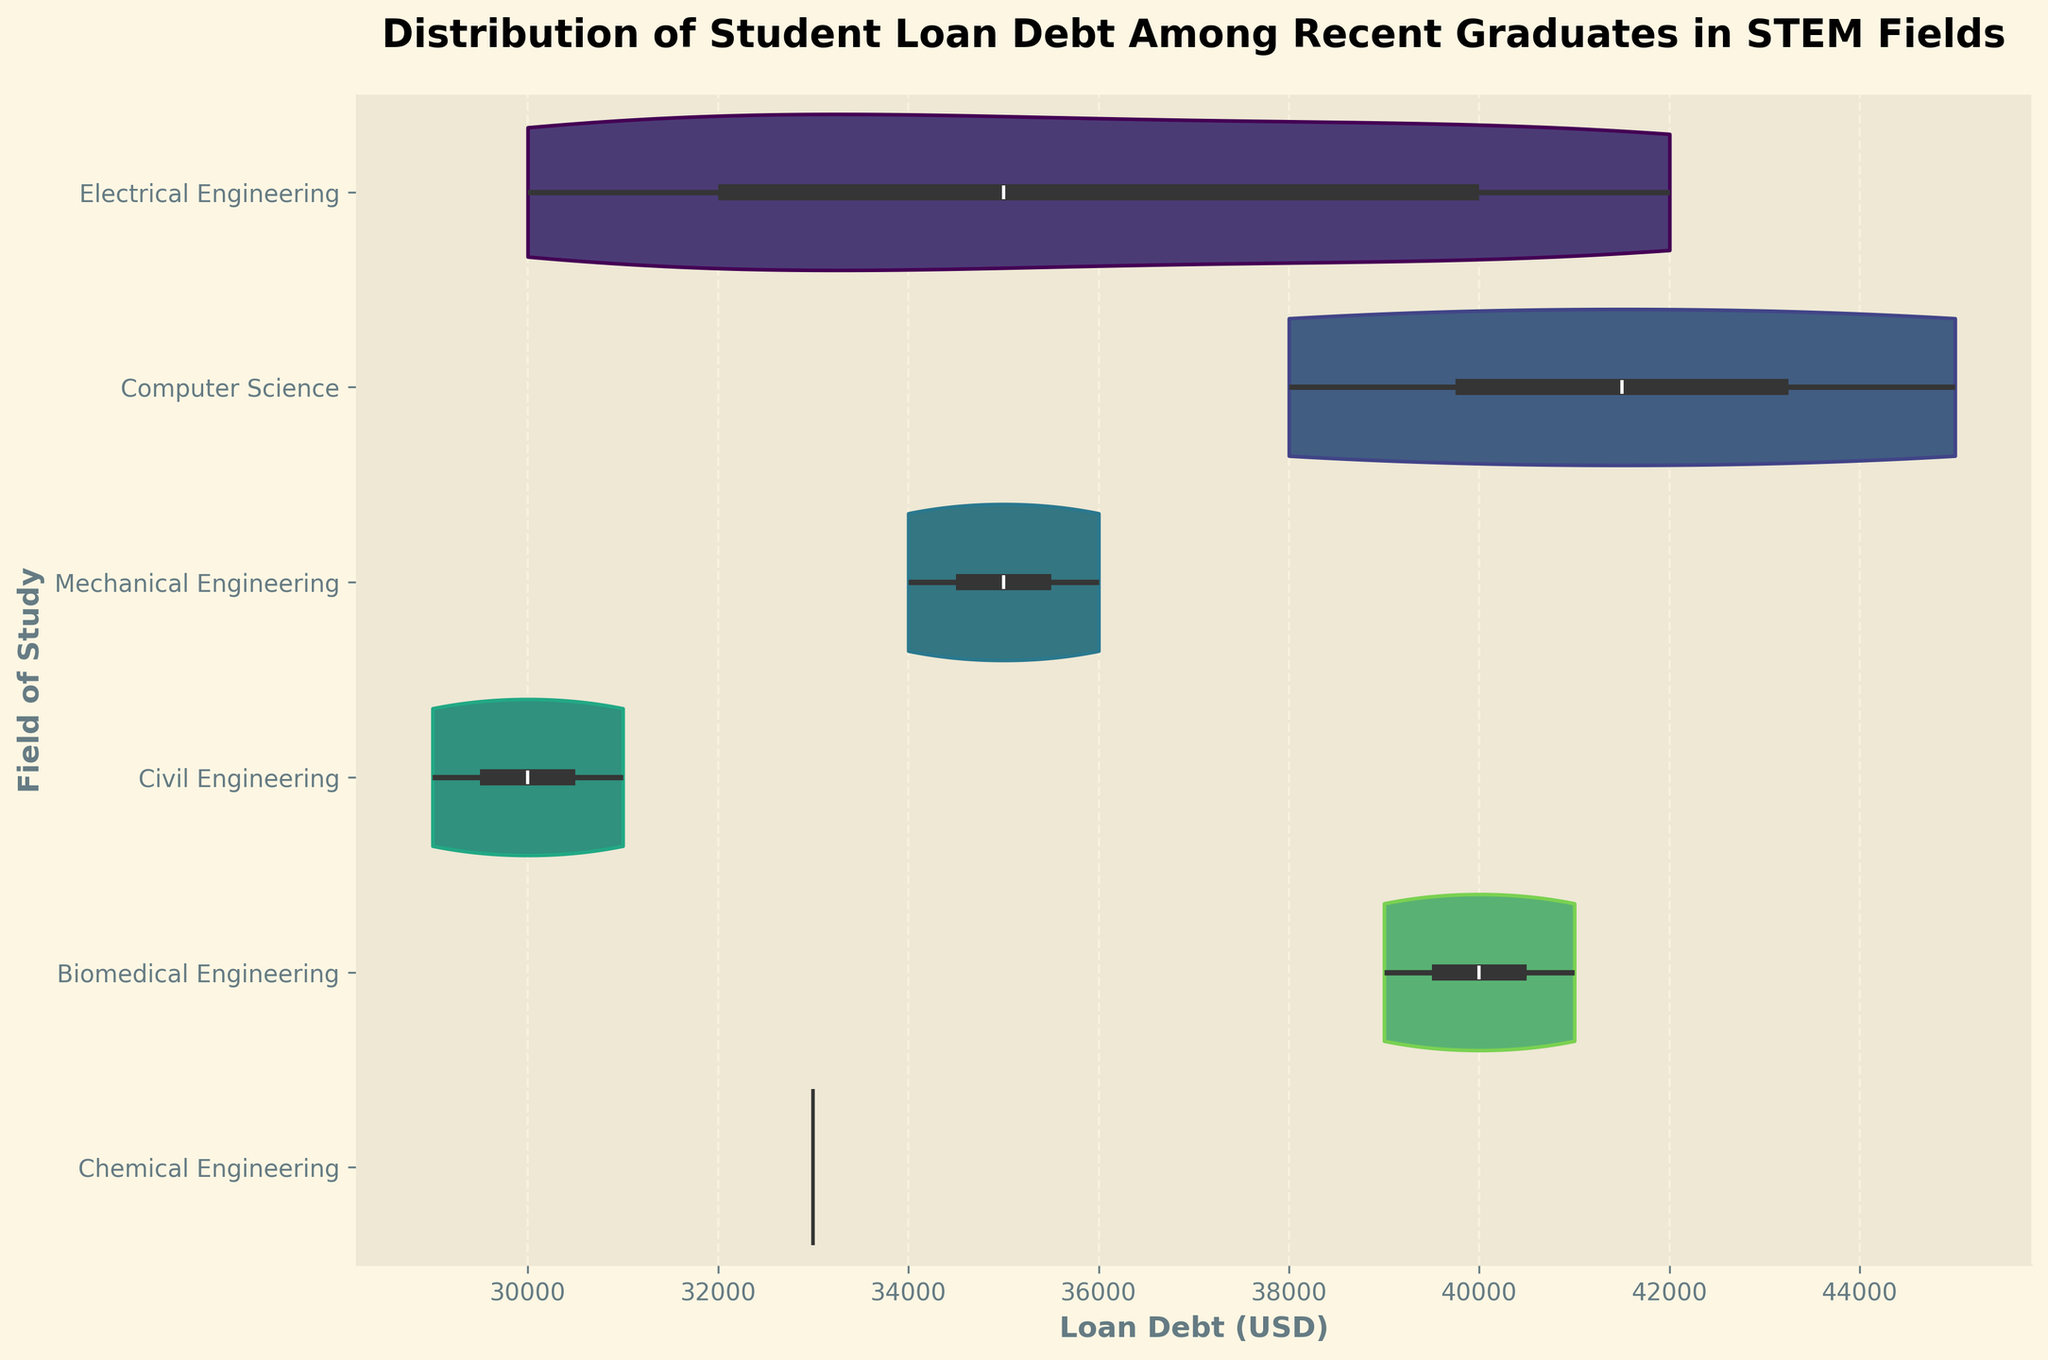What is the title of the figure? The title is typically found at the top of the figure and it describes the overall content of the plot.
Answer: Distribution of Student Loan Debt Among Recent Graduates in STEM Fields How many fields of study are represented in the figure? By counting the unique categories listed on the y-axis, you can determine the number of fields of study shown.
Answer: Five Which field of study has the widest distribution of loan debt? By observing the horizontal spread of each violin plot, the field with the widest spread will have the largest range of loan debt.
Answer: Electrical Engineering What is the median student loan debt for Computer Science graduates? The violin plots have an inner box plot that indicates the median. Look for the line representing the median within the Computer Science violin plot.
Answer: $41500 Which field has the highest median student loan debt and what is the value? Examine the inner box plots within each violin plot to identify the highest median value among all fields.
Answer: Computer Science, $41500 What is the range of student loan debt for Biomedical Engineering graduates? The range can be observed from the horizontal extent of the violin plot for Biomedical Engineering, noting its minimum and maximum values.
Answer: $39000 to $41000 Between Electrical Engineering and Civil Engineering, which field has a higher median loan debt? Compare the positions of the median lines within the violin plots for both fields.
Answer: Electrical Engineering What is the median loan debt for Chemical Engineering graduates? Check the inner box plot within the Chemical Engineering violin plot for the median value.
Answer: $33000 Which field of study has the narrowest distribution of loan debt? The narrowest violin plot indicates the field with the least variation in loan debt.
Answer: Civil Engineering By roughly how much does the median loan debt for Electrical Engineering graduates exceed that for Chemical Engineering graduates? Find the median values for both fields from their respective violin plots and calculate the difference.
Answer: $9000 